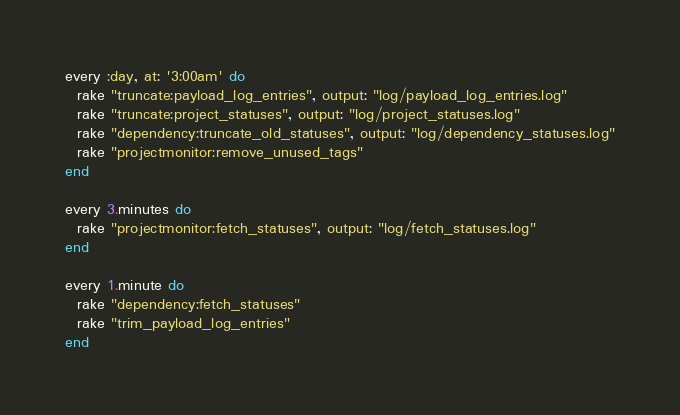Convert code to text. <code><loc_0><loc_0><loc_500><loc_500><_Ruby_>every :day, at: '3:00am' do
  rake "truncate:payload_log_entries", output: "log/payload_log_entries.log"
  rake "truncate:project_statuses", output: "log/project_statuses.log"
  rake "dependency:truncate_old_statuses", output: "log/dependency_statuses.log"
  rake "projectmonitor:remove_unused_tags"
end

every 3.minutes do
  rake "projectmonitor:fetch_statuses", output: "log/fetch_statuses.log"
end

every 1.minute do
  rake "dependency:fetch_statuses"
  rake "trim_payload_log_entries"
end
</code> 